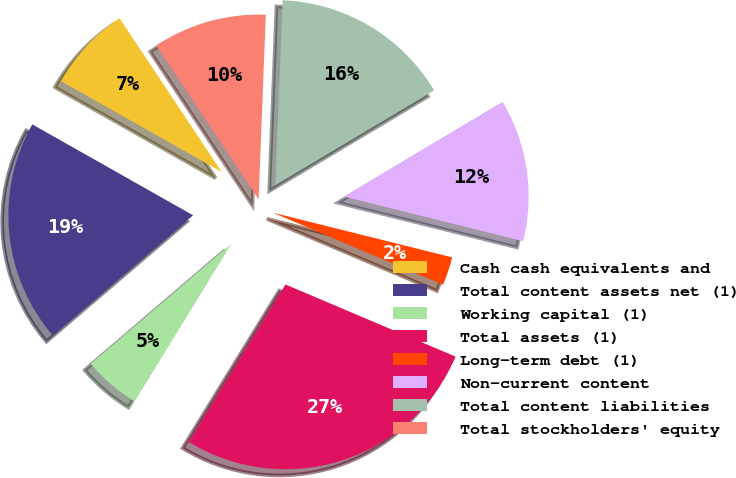Convert chart to OTSL. <chart><loc_0><loc_0><loc_500><loc_500><pie_chart><fcel>Cash cash equivalents and<fcel>Total content assets net (1)<fcel>Working capital (1)<fcel>Total assets (1)<fcel>Long-term debt (1)<fcel>Non-current content<fcel>Total content liabilities<fcel>Total stockholders' equity<nl><fcel>7.47%<fcel>19.45%<fcel>4.98%<fcel>27.38%<fcel>2.49%<fcel>12.45%<fcel>15.82%<fcel>9.96%<nl></chart> 